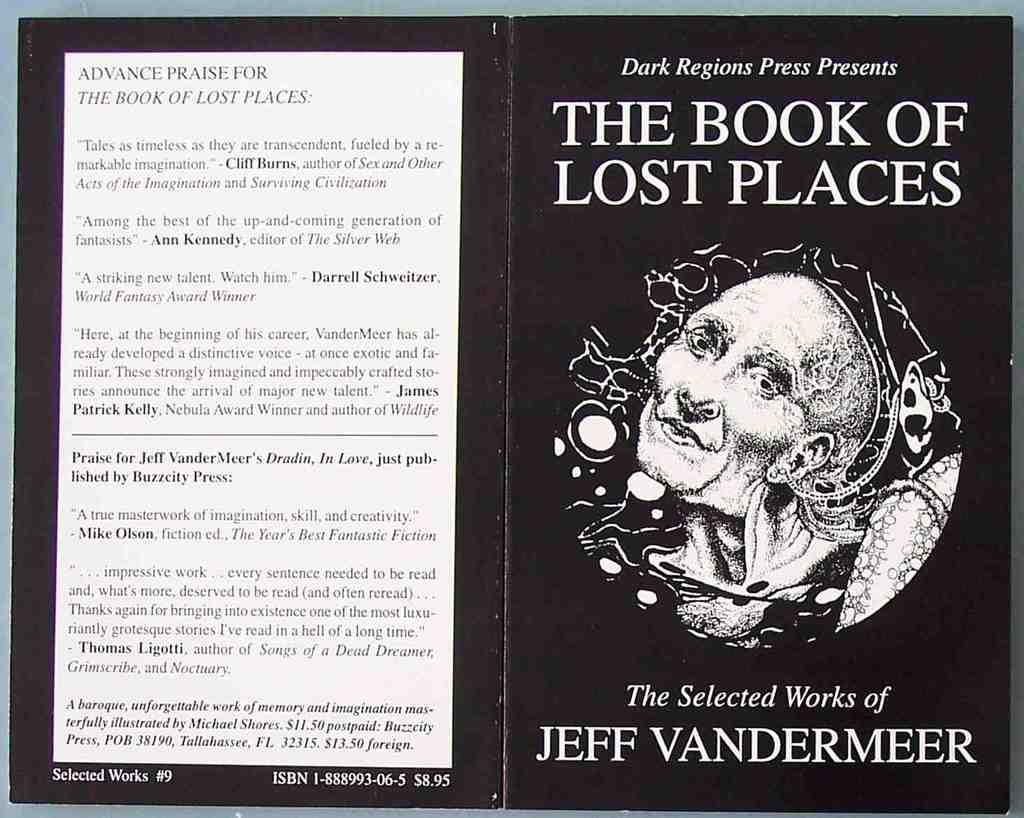<image>
Describe the image concisely. A black book with an image of a person on front titled The Book of Lost Places. 